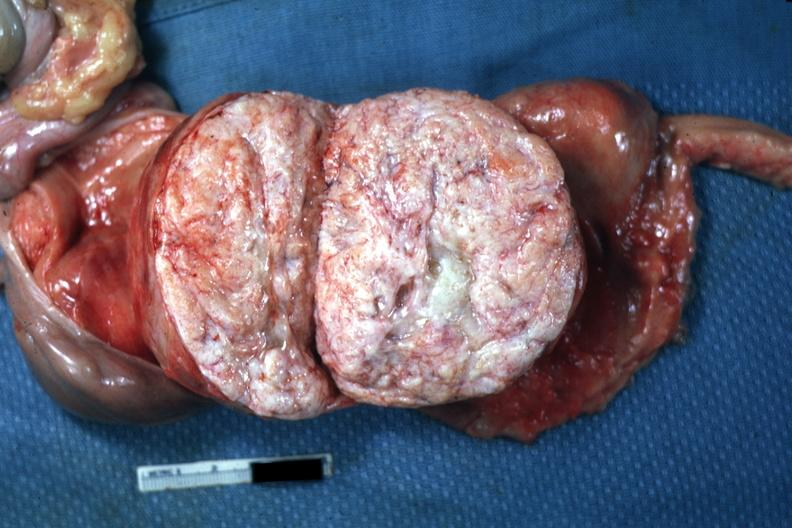has this myoma been sliced open like book can not readily see uterus itself myoma lesion is quite typical close-up photo?
Answer the question using a single word or phrase. Yes 